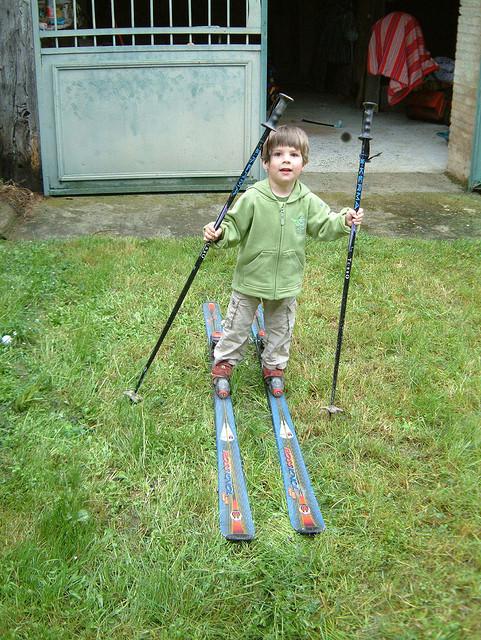Is there snow on the ground?
Give a very brief answer. No. Is this equipment the correct size for the child?
Write a very short answer. No. What is this kid trying to do?
Short answer required. Ski. 